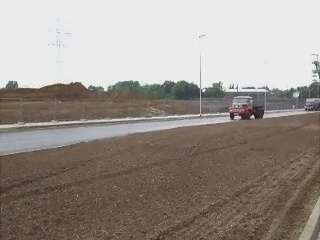Describe the objects in this image and their specific colors. I can see truck in white, gray, darkgray, black, and maroon tones and truck in white, gray, darkgray, and black tones in this image. 